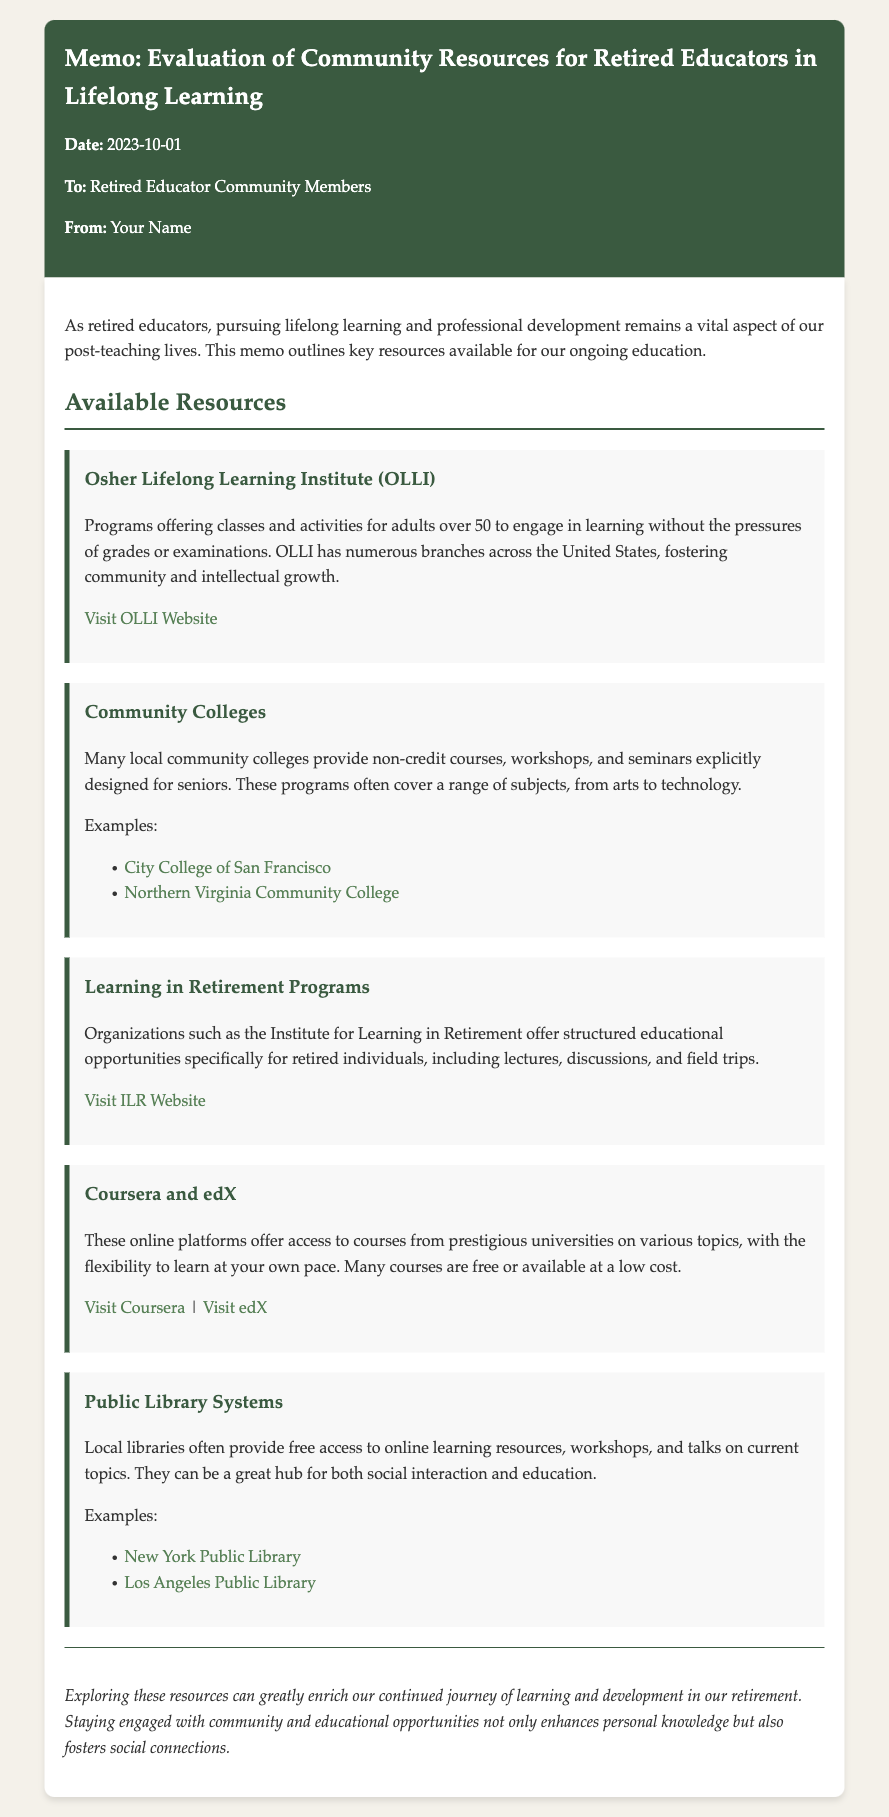What is the date of the memo? The date of the memo is explicitly stated at the beginning, which is October 1, 2023.
Answer: 2023-10-01 Who is the intended audience of the memo? The memo specifies its audience in the addressing section, mentioning "Retired Educator Community Members."
Answer: Retired Educator Community Members What organization offers programs without grades for adults over 50? The memo mentions this organization in the section about available resources, specifically referring to OLLI.
Answer: Osher Lifelong Learning Institute (OLLI) Which online platforms are mentioned for access to courses? The memo lists two online platforms that provide course access: Coursera and edX.
Answer: Coursera and edX How many examples of community colleges are provided? The document explicitly lists two examples of community colleges in the resources section.
Answer: Two What type of programs do Learning in Retirement Programs include? The memo outlines structured educational opportunities, including lectures, discussions, and field trips.
Answer: Structured educational opportunities What is the benefit of public library systems as mentioned in the memo? The memo emphasizes that local libraries provide access to online resources, workshops, and social interaction.
Answer: Free access to online learning resources What is the conclusion of the memo emphasizing? The conclusion section highlights the importance of exploring resources for personal knowledge and social connections.
Answer: Enrich our continued journey of learning and development 